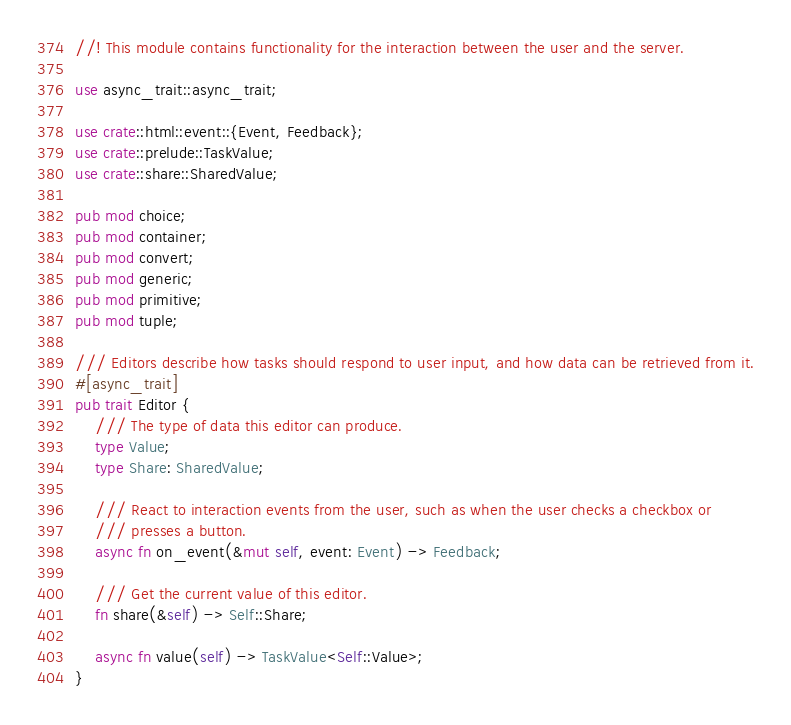<code> <loc_0><loc_0><loc_500><loc_500><_Rust_>//! This module contains functionality for the interaction between the user and the server.

use async_trait::async_trait;

use crate::html::event::{Event, Feedback};
use crate::prelude::TaskValue;
use crate::share::SharedValue;

pub mod choice;
pub mod container;
pub mod convert;
pub mod generic;
pub mod primitive;
pub mod tuple;

/// Editors describe how tasks should respond to user input, and how data can be retrieved from it.
#[async_trait]
pub trait Editor {
    /// The type of data this editor can produce.
    type Value;
    type Share: SharedValue;

    /// React to interaction events from the user, such as when the user checks a checkbox or
    /// presses a button.
    async fn on_event(&mut self, event: Event) -> Feedback;

    /// Get the current value of this editor.
    fn share(&self) -> Self::Share;

    async fn value(self) -> TaskValue<Self::Value>;
}
</code> 